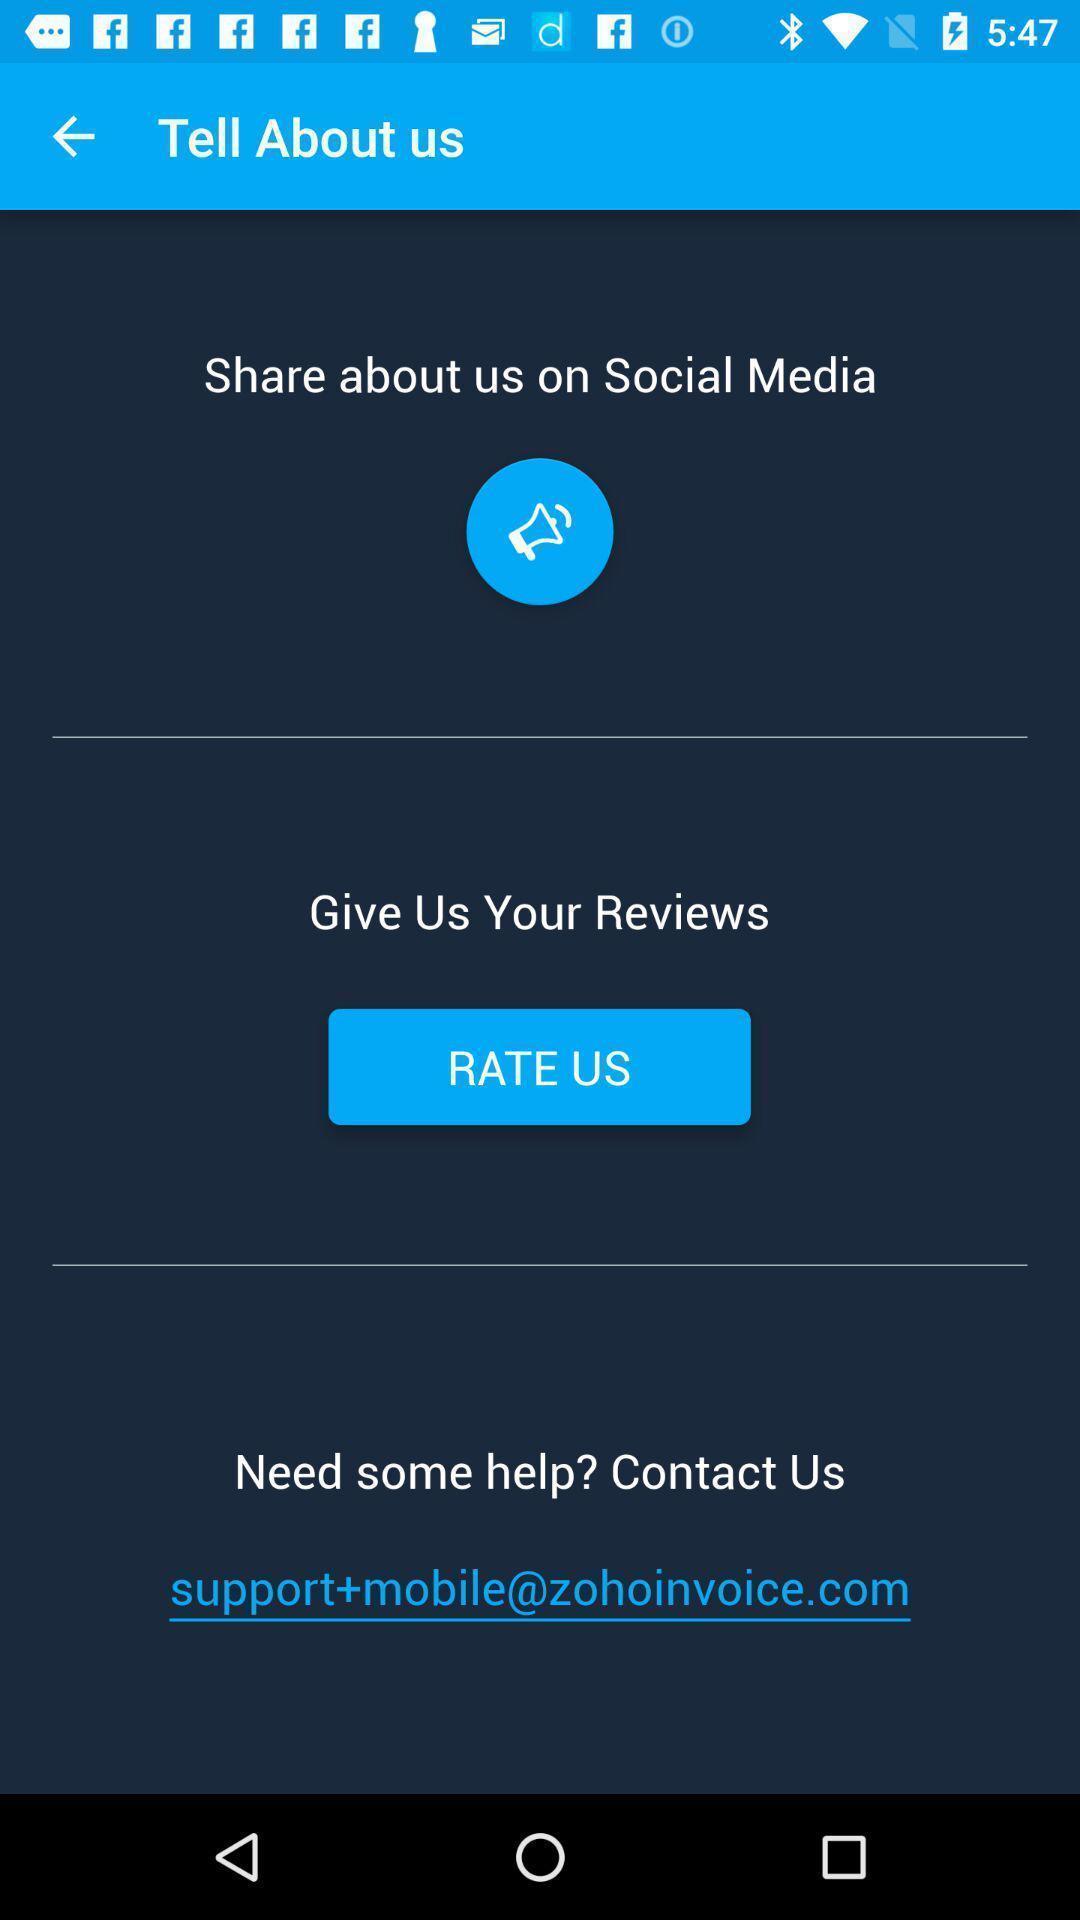What can you discern from this picture? Page displays to rate an application. 